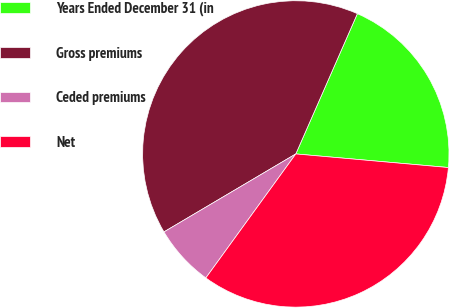<chart> <loc_0><loc_0><loc_500><loc_500><pie_chart><fcel>Years Ended December 31 (in<fcel>Gross premiums<fcel>Ceded premiums<fcel>Net<nl><fcel>19.83%<fcel>40.08%<fcel>6.51%<fcel>33.57%<nl></chart> 